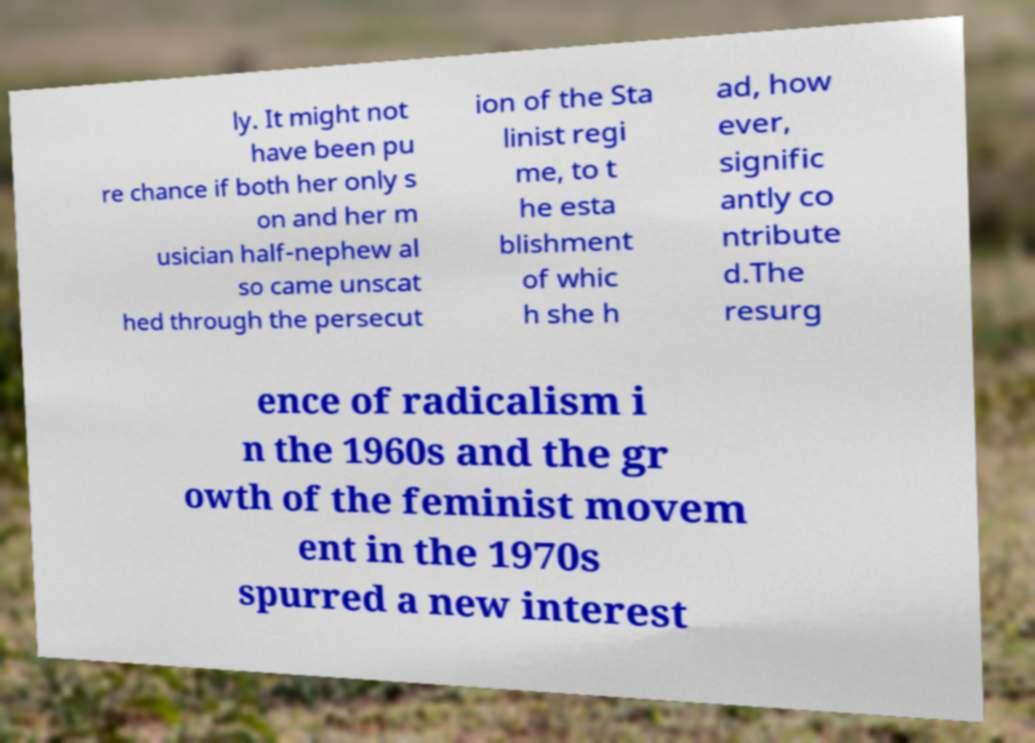What messages or text are displayed in this image? I need them in a readable, typed format. ly. It might not have been pu re chance if both her only s on and her m usician half-nephew al so came unscat hed through the persecut ion of the Sta linist regi me, to t he esta blishment of whic h she h ad, how ever, signific antly co ntribute d.The resurg ence of radicalism i n the 1960s and the gr owth of the feminist movem ent in the 1970s spurred a new interest 